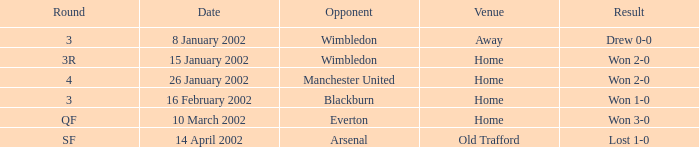What is the date when a confrontation with an adversary at wimbledon resulted in a 2-0 win? 15 January 2002. 